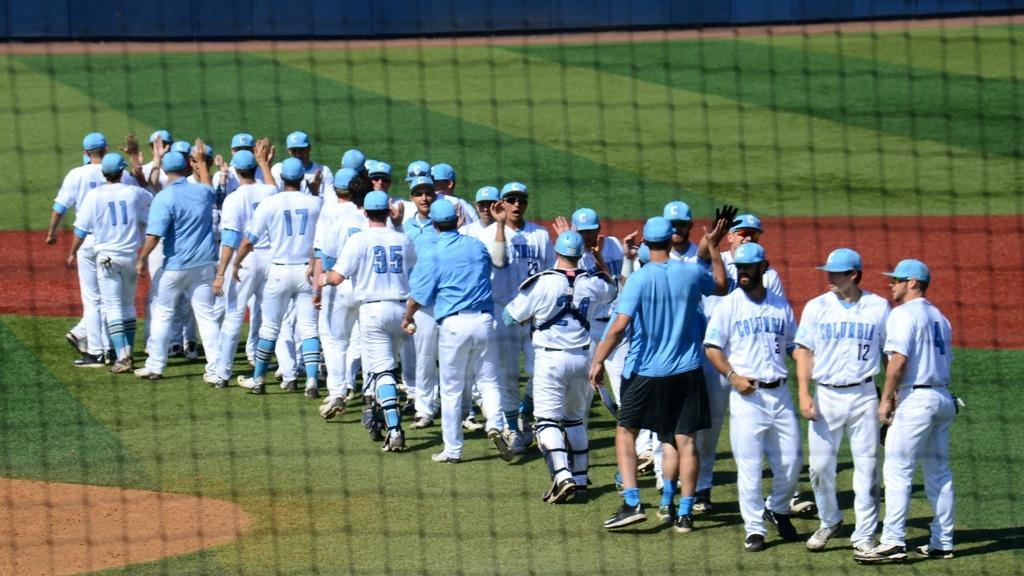<image>
Offer a succinct explanation of the picture presented. members for the columbia baseball team gathered on the field 